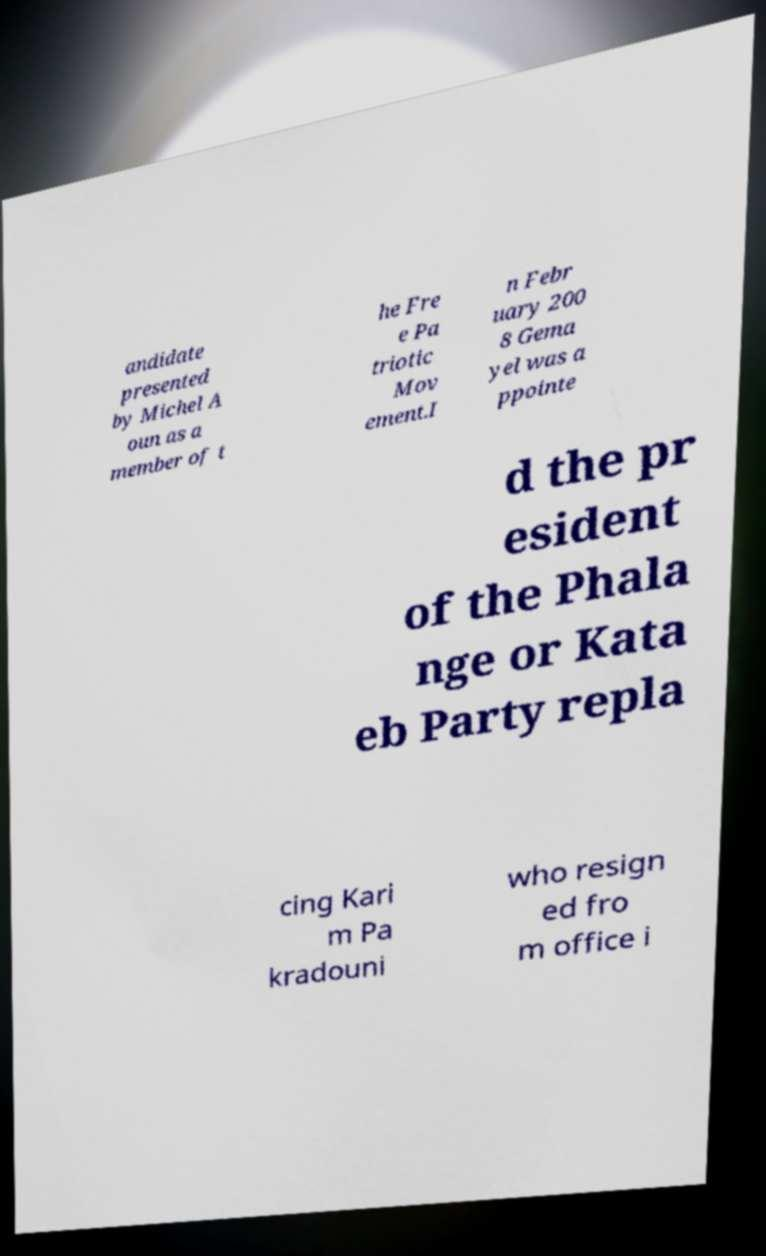Can you read and provide the text displayed in the image?This photo seems to have some interesting text. Can you extract and type it out for me? andidate presented by Michel A oun as a member of t he Fre e Pa triotic Mov ement.I n Febr uary 200 8 Gema yel was a ppointe d the pr esident of the Phala nge or Kata eb Party repla cing Kari m Pa kradouni who resign ed fro m office i 